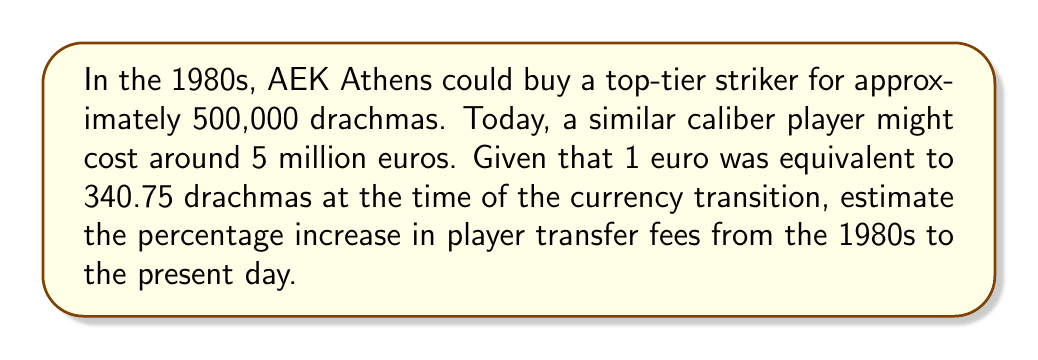Teach me how to tackle this problem. To solve this problem, we'll follow these steps:

1. Convert the 1980s fee from drachmas to euros:
   $$ \text{1980s fee in euros} = \frac{500,000 \text{ drachmas}}{340.75 \text{ drachmas/euro}} = 1,467.35 \text{ euros} $$

2. Calculate the absolute increase in fees:
   $$ \text{Increase} = 5,000,000 - 1,467.35 = 4,998,532.65 \text{ euros} $$

3. Calculate the percentage increase using the formula:
   $$ \text{Percentage increase} = \frac{\text{Increase}}{\text{Original amount}} \times 100\% $$

   $$ \text{Percentage increase} = \frac{4,998,532.65}{1,467.35} \times 100\% = 3,406.53\% $$

Thus, the transfer fees have increased by approximately 3,407% from the 1980s to the present day.
Answer: 3,407% 